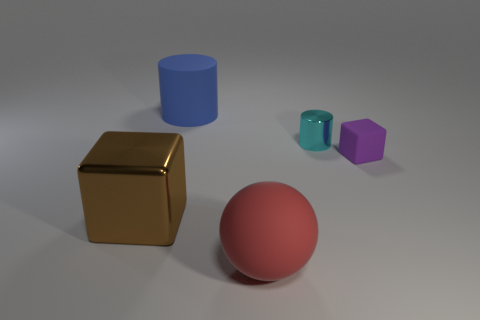Can you describe the lighting in this scene? The lighting in the scene is diffuse and soft, creating gentle shadows on the ground. There doesn't appear to be a direct, harsh light source. Instead, the illumination seems uniformly scattered, which can be indicative of an overcast sky or a photography studio setup with softboxes that reduce shadows and glare on the objects. 